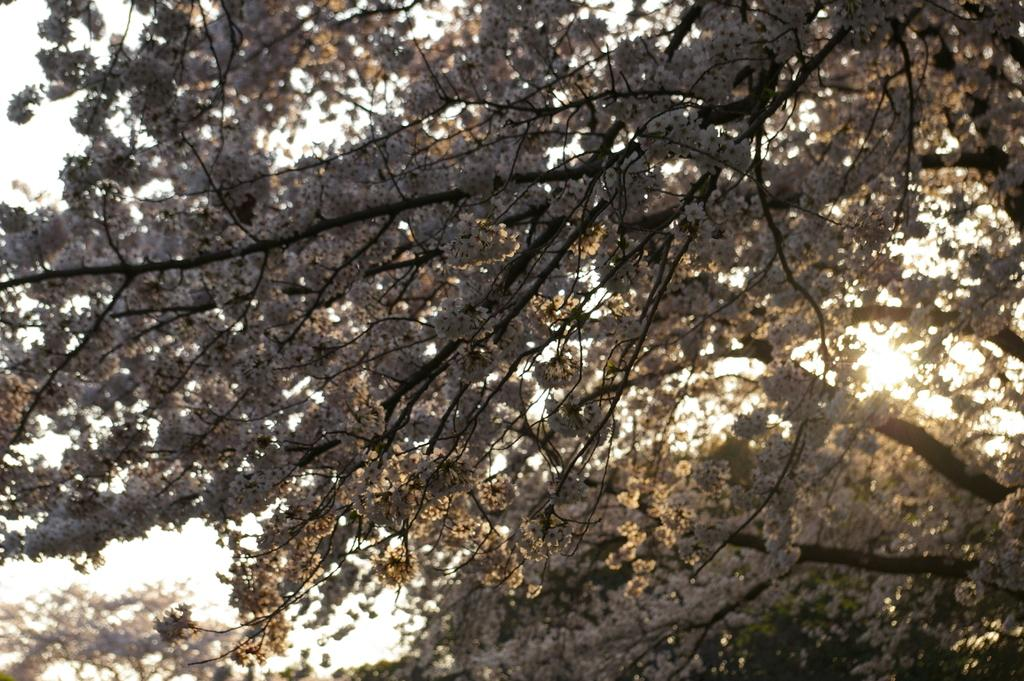What type of vegetation is visible in the foreground of the image? There are trees in the foreground area of the image. What part of the natural environment is visible in the background of the image? The sky is visible in the background of the image. What type of cake is being served on the wall in the image? There is no cake or wall present in the image; it features trees in the foreground and the sky in the background. How many toes can be seen in the image? There are no toes visible in the image. 